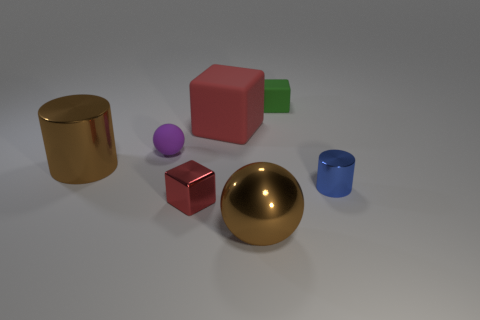What material is the other block that is the same color as the shiny cube?
Make the answer very short. Rubber. The cube that is the same color as the large matte object is what size?
Ensure brevity in your answer.  Small. What number of other objects are there of the same shape as the purple thing?
Offer a terse response. 1. Does the blue thing have the same shape as the brown metallic object on the left side of the large ball?
Your answer should be very brief. Yes. How many large brown things are behind the green rubber object?
Your answer should be very brief. 0. Is there anything else that is the same material as the large cylinder?
Provide a succinct answer. Yes. There is a metal object that is to the right of the green cube; does it have the same shape as the tiny green thing?
Make the answer very short. No. The rubber thing on the right side of the big red object is what color?
Keep it short and to the point. Green. There is a red thing that is made of the same material as the small cylinder; what is its shape?
Your answer should be compact. Cube. Is there any other thing of the same color as the metal ball?
Your response must be concise. Yes. 